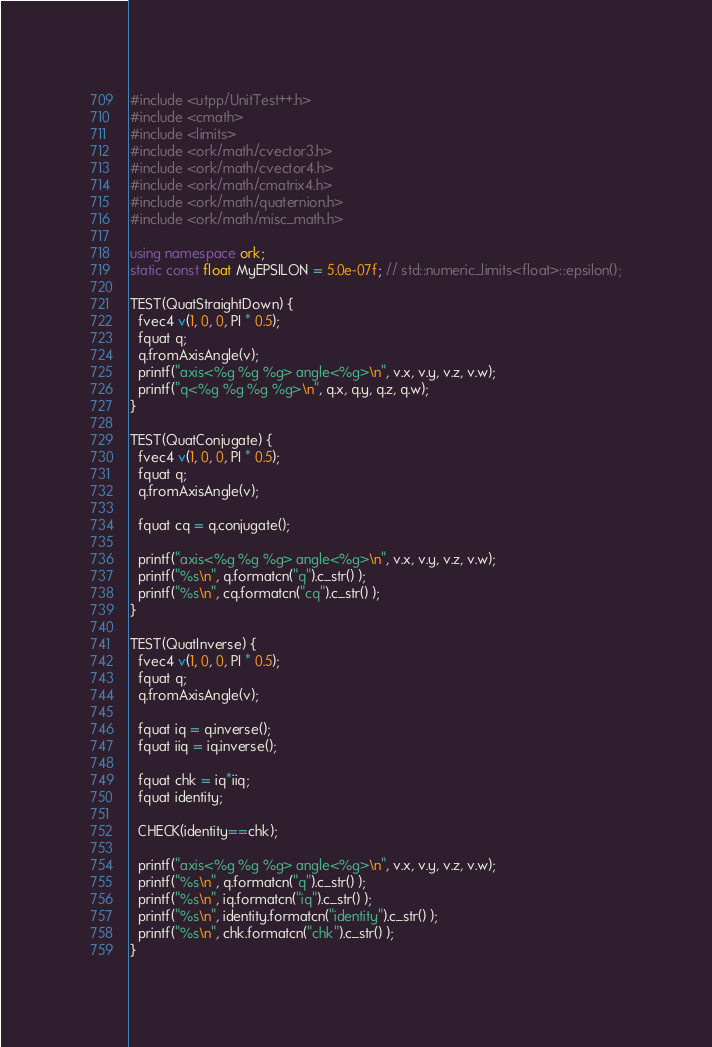Convert code to text. <code><loc_0><loc_0><loc_500><loc_500><_C++_>#include <utpp/UnitTest++.h>
#include <cmath>
#include <limits>
#include <ork/math/cvector3.h>
#include <ork/math/cvector4.h>
#include <ork/math/cmatrix4.h>
#include <ork/math/quaternion.h>
#include <ork/math/misc_math.h>

using namespace ork;
static const float MyEPSILON = 5.0e-07f; // std::numeric_limits<float>::epsilon();

TEST(QuatStraightDown) {
  fvec4 v(1, 0, 0, PI * 0.5);
  fquat q;
  q.fromAxisAngle(v);
  printf("axis<%g %g %g> angle<%g>\n", v.x, v.y, v.z, v.w);
  printf("q<%g %g %g %g>\n", q.x, q.y, q.z, q.w);
}

TEST(QuatConjugate) {
  fvec4 v(1, 0, 0, PI * 0.5);
  fquat q;
  q.fromAxisAngle(v);

  fquat cq = q.conjugate();

  printf("axis<%g %g %g> angle<%g>\n", v.x, v.y, v.z, v.w);
  printf("%s\n", q.formatcn("q").c_str() );
  printf("%s\n", cq.formatcn("cq").c_str() );
}

TEST(QuatInverse) {
  fvec4 v(1, 0, 0, PI * 0.5);
  fquat q;
  q.fromAxisAngle(v);

  fquat iq = q.inverse();
  fquat iiq = iq.inverse();

  fquat chk = iq*iiq;
  fquat identity;

  CHECK(identity==chk);

  printf("axis<%g %g %g> angle<%g>\n", v.x, v.y, v.z, v.w);
  printf("%s\n", q.formatcn("q").c_str() );
  printf("%s\n", iq.formatcn("iq").c_str() );
  printf("%s\n", identity.formatcn("identity").c_str() );
  printf("%s\n", chk.formatcn("chk").c_str() );
}
</code> 